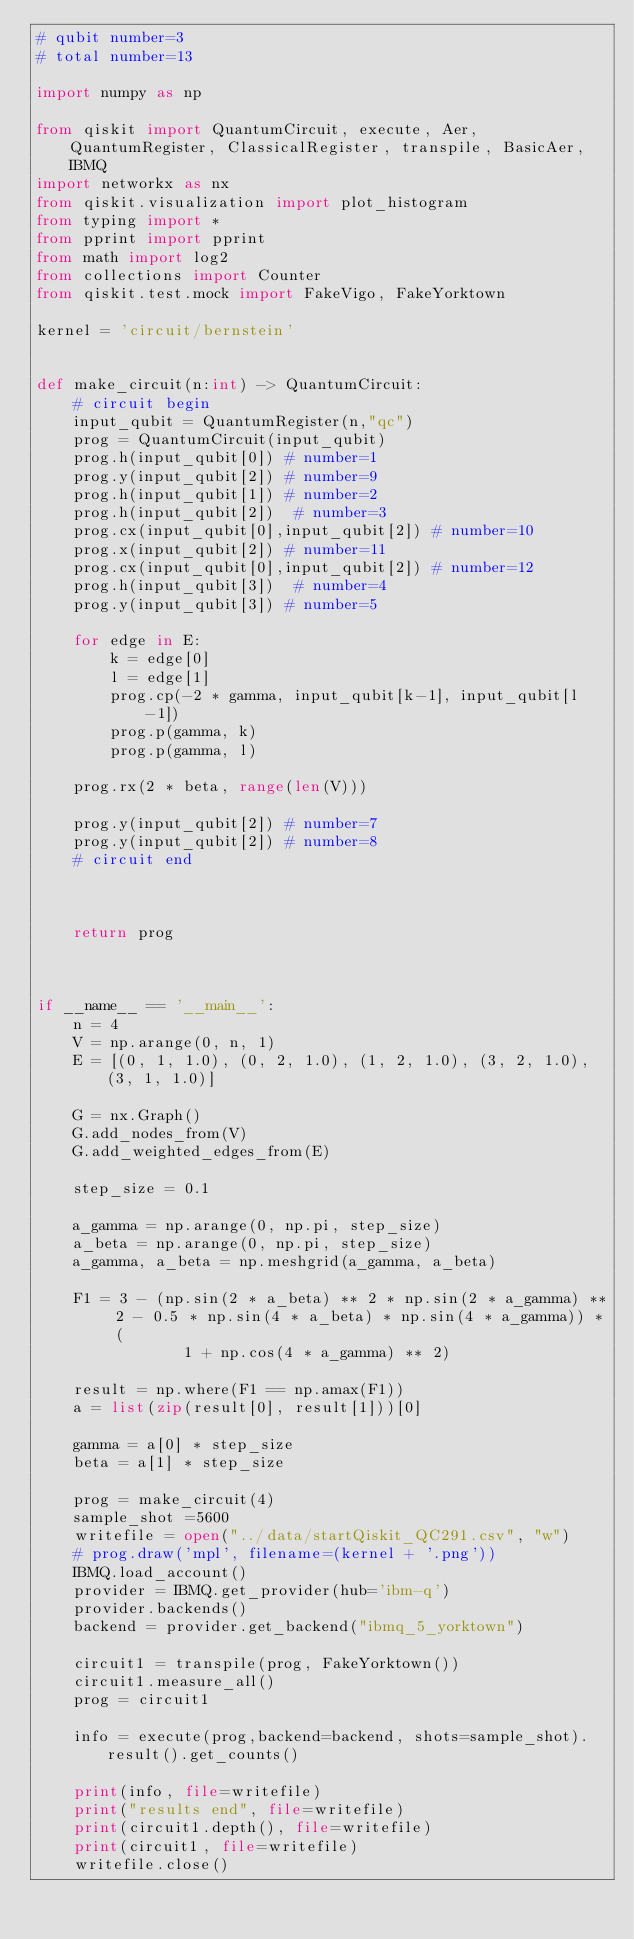Convert code to text. <code><loc_0><loc_0><loc_500><loc_500><_Python_># qubit number=3
# total number=13

import numpy as np

from qiskit import QuantumCircuit, execute, Aer, QuantumRegister, ClassicalRegister, transpile, BasicAer, IBMQ
import networkx as nx
from qiskit.visualization import plot_histogram
from typing import *
from pprint import pprint
from math import log2
from collections import Counter
from qiskit.test.mock import FakeVigo, FakeYorktown

kernel = 'circuit/bernstein'


def make_circuit(n:int) -> QuantumCircuit:
    # circuit begin
    input_qubit = QuantumRegister(n,"qc")
    prog = QuantumCircuit(input_qubit)
    prog.h(input_qubit[0]) # number=1
    prog.y(input_qubit[2]) # number=9
    prog.h(input_qubit[1]) # number=2
    prog.h(input_qubit[2])  # number=3
    prog.cx(input_qubit[0],input_qubit[2]) # number=10
    prog.x(input_qubit[2]) # number=11
    prog.cx(input_qubit[0],input_qubit[2]) # number=12
    prog.h(input_qubit[3])  # number=4
    prog.y(input_qubit[3]) # number=5

    for edge in E:
        k = edge[0]
        l = edge[1]
        prog.cp(-2 * gamma, input_qubit[k-1], input_qubit[l-1])
        prog.p(gamma, k)
        prog.p(gamma, l)

    prog.rx(2 * beta, range(len(V)))

    prog.y(input_qubit[2]) # number=7
    prog.y(input_qubit[2]) # number=8
    # circuit end



    return prog



if __name__ == '__main__':
    n = 4
    V = np.arange(0, n, 1)
    E = [(0, 1, 1.0), (0, 2, 1.0), (1, 2, 1.0), (3, 2, 1.0), (3, 1, 1.0)]

    G = nx.Graph()
    G.add_nodes_from(V)
    G.add_weighted_edges_from(E)

    step_size = 0.1

    a_gamma = np.arange(0, np.pi, step_size)
    a_beta = np.arange(0, np.pi, step_size)
    a_gamma, a_beta = np.meshgrid(a_gamma, a_beta)

    F1 = 3 - (np.sin(2 * a_beta) ** 2 * np.sin(2 * a_gamma) ** 2 - 0.5 * np.sin(4 * a_beta) * np.sin(4 * a_gamma)) * (
                1 + np.cos(4 * a_gamma) ** 2)

    result = np.where(F1 == np.amax(F1))
    a = list(zip(result[0], result[1]))[0]

    gamma = a[0] * step_size
    beta = a[1] * step_size

    prog = make_circuit(4)
    sample_shot =5600
    writefile = open("../data/startQiskit_QC291.csv", "w")
    # prog.draw('mpl', filename=(kernel + '.png'))
    IBMQ.load_account() 
    provider = IBMQ.get_provider(hub='ibm-q') 
    provider.backends()
    backend = provider.get_backend("ibmq_5_yorktown")

    circuit1 = transpile(prog, FakeYorktown())
    circuit1.measure_all()
    prog = circuit1

    info = execute(prog,backend=backend, shots=sample_shot).result().get_counts()

    print(info, file=writefile)
    print("results end", file=writefile)
    print(circuit1.depth(), file=writefile)
    print(circuit1, file=writefile)
    writefile.close()
</code> 